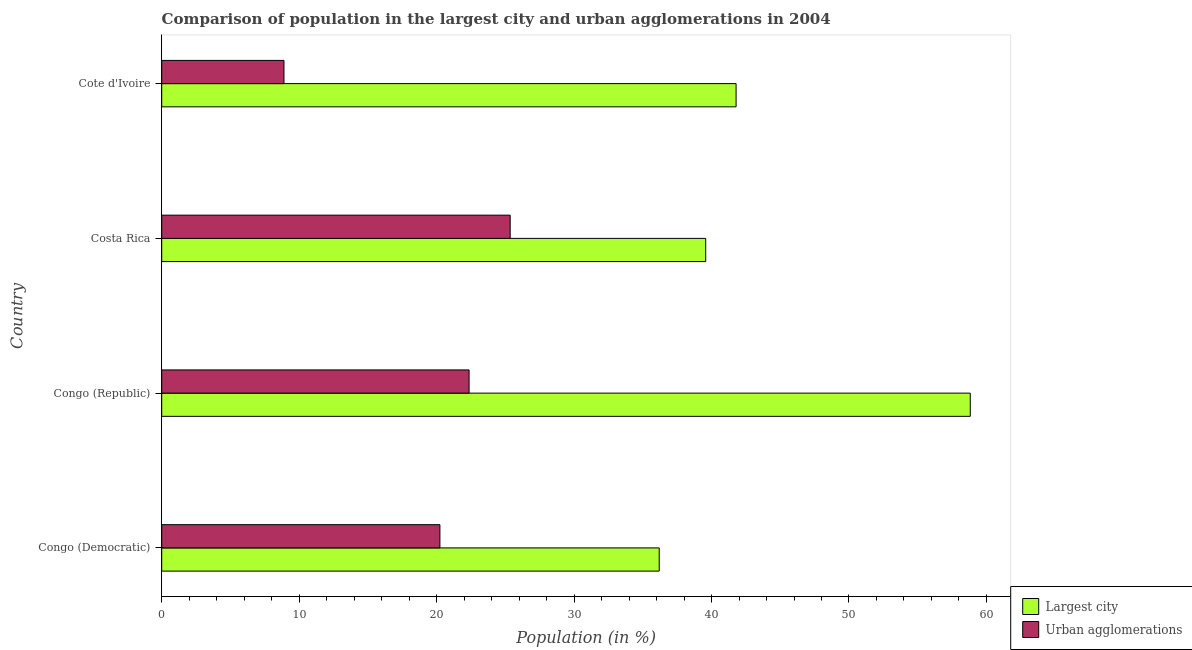How many different coloured bars are there?
Your answer should be compact. 2. Are the number of bars per tick equal to the number of legend labels?
Your response must be concise. Yes. What is the label of the 2nd group of bars from the top?
Your answer should be very brief. Costa Rica. What is the population in urban agglomerations in Congo (Democratic)?
Offer a terse response. 20.24. Across all countries, what is the maximum population in the largest city?
Your answer should be compact. 58.82. Across all countries, what is the minimum population in the largest city?
Give a very brief answer. 36.2. In which country was the population in urban agglomerations minimum?
Offer a very short reply. Cote d'Ivoire. What is the total population in the largest city in the graph?
Make the answer very short. 176.38. What is the difference between the population in urban agglomerations in Costa Rica and that in Cote d'Ivoire?
Ensure brevity in your answer.  16.46. What is the difference between the population in urban agglomerations in Costa Rica and the population in the largest city in Congo (Democratic)?
Keep it short and to the point. -10.84. What is the average population in urban agglomerations per country?
Keep it short and to the point. 19.21. What is the difference between the population in urban agglomerations and population in the largest city in Congo (Republic)?
Your answer should be very brief. -36.46. What is the ratio of the population in the largest city in Congo (Democratic) to that in Costa Rica?
Offer a terse response. 0.92. What is the difference between the highest and the second highest population in urban agglomerations?
Your answer should be compact. 2.99. What is the difference between the highest and the lowest population in the largest city?
Offer a terse response. 22.63. What does the 1st bar from the top in Congo (Republic) represents?
Offer a very short reply. Urban agglomerations. What does the 2nd bar from the bottom in Congo (Democratic) represents?
Your response must be concise. Urban agglomerations. How many bars are there?
Your response must be concise. 8. What is the difference between two consecutive major ticks on the X-axis?
Make the answer very short. 10. How are the legend labels stacked?
Provide a short and direct response. Vertical. What is the title of the graph?
Give a very brief answer. Comparison of population in the largest city and urban agglomerations in 2004. Does "Diesel" appear as one of the legend labels in the graph?
Give a very brief answer. No. What is the label or title of the X-axis?
Your response must be concise. Population (in %). What is the Population (in %) in Largest city in Congo (Democratic)?
Offer a terse response. 36.2. What is the Population (in %) of Urban agglomerations in Congo (Democratic)?
Your answer should be very brief. 20.24. What is the Population (in %) in Largest city in Congo (Republic)?
Keep it short and to the point. 58.82. What is the Population (in %) of Urban agglomerations in Congo (Republic)?
Offer a terse response. 22.36. What is the Population (in %) of Largest city in Costa Rica?
Give a very brief answer. 39.58. What is the Population (in %) in Urban agglomerations in Costa Rica?
Ensure brevity in your answer.  25.35. What is the Population (in %) in Largest city in Cote d'Ivoire?
Your answer should be compact. 41.79. What is the Population (in %) in Urban agglomerations in Cote d'Ivoire?
Make the answer very short. 8.89. Across all countries, what is the maximum Population (in %) of Largest city?
Make the answer very short. 58.82. Across all countries, what is the maximum Population (in %) in Urban agglomerations?
Ensure brevity in your answer.  25.35. Across all countries, what is the minimum Population (in %) of Largest city?
Provide a short and direct response. 36.2. Across all countries, what is the minimum Population (in %) of Urban agglomerations?
Provide a short and direct response. 8.89. What is the total Population (in %) of Largest city in the graph?
Give a very brief answer. 176.38. What is the total Population (in %) in Urban agglomerations in the graph?
Offer a very short reply. 76.84. What is the difference between the Population (in %) in Largest city in Congo (Democratic) and that in Congo (Republic)?
Provide a succinct answer. -22.63. What is the difference between the Population (in %) of Urban agglomerations in Congo (Democratic) and that in Congo (Republic)?
Keep it short and to the point. -2.12. What is the difference between the Population (in %) in Largest city in Congo (Democratic) and that in Costa Rica?
Ensure brevity in your answer.  -3.38. What is the difference between the Population (in %) of Urban agglomerations in Congo (Democratic) and that in Costa Rica?
Your answer should be very brief. -5.11. What is the difference between the Population (in %) in Largest city in Congo (Democratic) and that in Cote d'Ivoire?
Make the answer very short. -5.59. What is the difference between the Population (in %) in Urban agglomerations in Congo (Democratic) and that in Cote d'Ivoire?
Provide a succinct answer. 11.34. What is the difference between the Population (in %) in Largest city in Congo (Republic) and that in Costa Rica?
Offer a terse response. 19.25. What is the difference between the Population (in %) of Urban agglomerations in Congo (Republic) and that in Costa Rica?
Offer a terse response. -2.99. What is the difference between the Population (in %) of Largest city in Congo (Republic) and that in Cote d'Ivoire?
Ensure brevity in your answer.  17.04. What is the difference between the Population (in %) of Urban agglomerations in Congo (Republic) and that in Cote d'Ivoire?
Ensure brevity in your answer.  13.47. What is the difference between the Population (in %) of Largest city in Costa Rica and that in Cote d'Ivoire?
Keep it short and to the point. -2.21. What is the difference between the Population (in %) of Urban agglomerations in Costa Rica and that in Cote d'Ivoire?
Your answer should be very brief. 16.46. What is the difference between the Population (in %) of Largest city in Congo (Democratic) and the Population (in %) of Urban agglomerations in Congo (Republic)?
Your answer should be very brief. 13.83. What is the difference between the Population (in %) in Largest city in Congo (Democratic) and the Population (in %) in Urban agglomerations in Costa Rica?
Ensure brevity in your answer.  10.84. What is the difference between the Population (in %) in Largest city in Congo (Democratic) and the Population (in %) in Urban agglomerations in Cote d'Ivoire?
Provide a short and direct response. 27.3. What is the difference between the Population (in %) in Largest city in Congo (Republic) and the Population (in %) in Urban agglomerations in Costa Rica?
Make the answer very short. 33.47. What is the difference between the Population (in %) of Largest city in Congo (Republic) and the Population (in %) of Urban agglomerations in Cote d'Ivoire?
Your response must be concise. 49.93. What is the difference between the Population (in %) of Largest city in Costa Rica and the Population (in %) of Urban agglomerations in Cote d'Ivoire?
Offer a terse response. 30.68. What is the average Population (in %) in Largest city per country?
Your response must be concise. 44.09. What is the average Population (in %) in Urban agglomerations per country?
Provide a short and direct response. 19.21. What is the difference between the Population (in %) of Largest city and Population (in %) of Urban agglomerations in Congo (Democratic)?
Your answer should be very brief. 15.96. What is the difference between the Population (in %) of Largest city and Population (in %) of Urban agglomerations in Congo (Republic)?
Make the answer very short. 36.46. What is the difference between the Population (in %) of Largest city and Population (in %) of Urban agglomerations in Costa Rica?
Provide a succinct answer. 14.23. What is the difference between the Population (in %) in Largest city and Population (in %) in Urban agglomerations in Cote d'Ivoire?
Ensure brevity in your answer.  32.89. What is the ratio of the Population (in %) in Largest city in Congo (Democratic) to that in Congo (Republic)?
Ensure brevity in your answer.  0.62. What is the ratio of the Population (in %) in Urban agglomerations in Congo (Democratic) to that in Congo (Republic)?
Offer a very short reply. 0.91. What is the ratio of the Population (in %) in Largest city in Congo (Democratic) to that in Costa Rica?
Provide a short and direct response. 0.91. What is the ratio of the Population (in %) in Urban agglomerations in Congo (Democratic) to that in Costa Rica?
Give a very brief answer. 0.8. What is the ratio of the Population (in %) of Largest city in Congo (Democratic) to that in Cote d'Ivoire?
Provide a succinct answer. 0.87. What is the ratio of the Population (in %) of Urban agglomerations in Congo (Democratic) to that in Cote d'Ivoire?
Your answer should be compact. 2.28. What is the ratio of the Population (in %) of Largest city in Congo (Republic) to that in Costa Rica?
Your answer should be compact. 1.49. What is the ratio of the Population (in %) of Urban agglomerations in Congo (Republic) to that in Costa Rica?
Provide a succinct answer. 0.88. What is the ratio of the Population (in %) of Largest city in Congo (Republic) to that in Cote d'Ivoire?
Provide a succinct answer. 1.41. What is the ratio of the Population (in %) of Urban agglomerations in Congo (Republic) to that in Cote d'Ivoire?
Ensure brevity in your answer.  2.51. What is the ratio of the Population (in %) in Largest city in Costa Rica to that in Cote d'Ivoire?
Make the answer very short. 0.95. What is the ratio of the Population (in %) of Urban agglomerations in Costa Rica to that in Cote d'Ivoire?
Offer a very short reply. 2.85. What is the difference between the highest and the second highest Population (in %) of Largest city?
Offer a terse response. 17.04. What is the difference between the highest and the second highest Population (in %) of Urban agglomerations?
Keep it short and to the point. 2.99. What is the difference between the highest and the lowest Population (in %) in Largest city?
Provide a succinct answer. 22.63. What is the difference between the highest and the lowest Population (in %) in Urban agglomerations?
Make the answer very short. 16.46. 